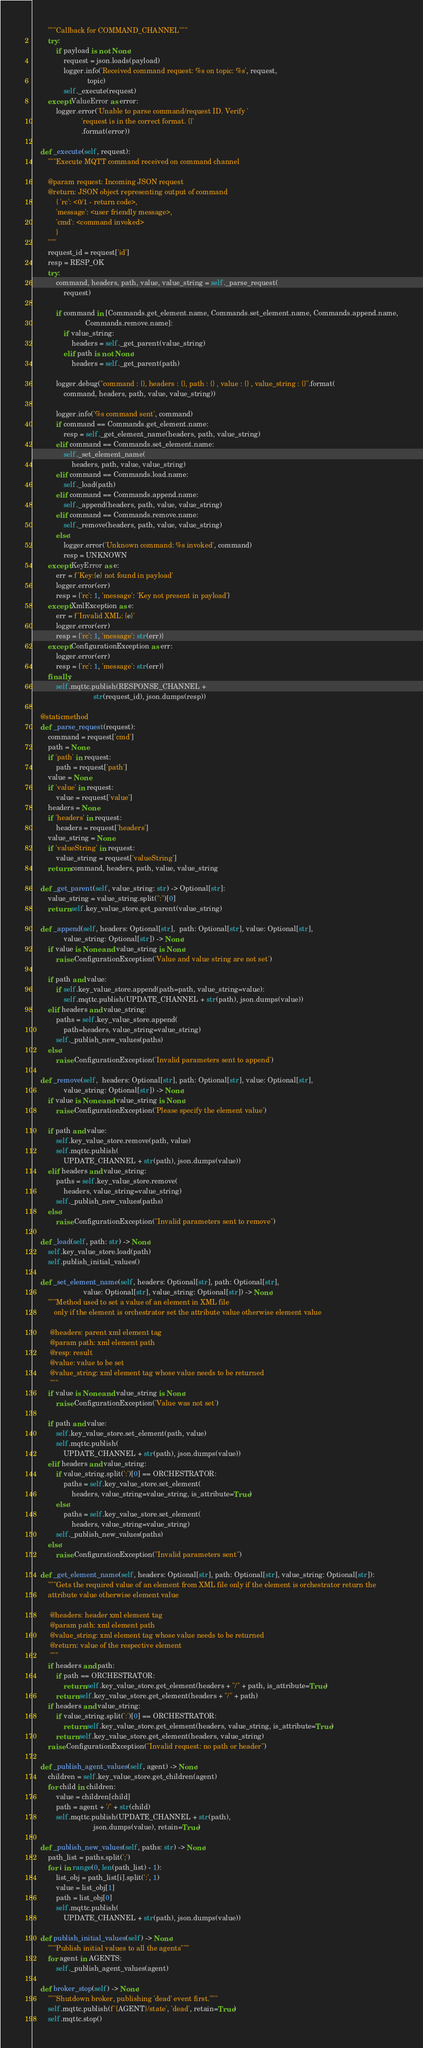Convert code to text. <code><loc_0><loc_0><loc_500><loc_500><_Python_>        """Callback for COMMAND_CHANNEL"""
        try:
            if payload is not None:
                request = json.loads(payload)
                logger.info('Received command request: %s on topic: %s', request,
                            topic)
                self._execute(request)
        except ValueError as error:
            logger.error('Unable to parse command/request ID. Verify '
                         'request is in the correct format. {}'
                         .format(error))

    def _execute(self, request):
        """Execute MQTT command received on command channel

        @param request: Incoming JSON request
        @return: JSON object representing output of command
            { 'rc': <0/1 - return code>,
            'message': <user friendly message>,
            'cmd': <command invoked>
            }
        """
        request_id = request['id']
        resp = RESP_OK
        try:
            command, headers, path, value, value_string = self._parse_request(
                request)

            if command in [Commands.get_element.name, Commands.set_element.name, Commands.append.name,
                           Commands.remove.name]:
                if value_string:
                    headers = self._get_parent(value_string)
                elif path is not None:
                    headers = self._get_parent(path)

            logger.debug("command : {}, headers : {}, path : {} , value : {} , value_string : {}".format(
                command, headers, path, value, value_string))

            logger.info('%s command sent', command)
            if command == Commands.get_element.name:
                resp = self._get_element_name(headers, path, value_string)
            elif command == Commands.set_element.name:
                self._set_element_name(
                    headers, path, value, value_string)
            elif command == Commands.load.name:
                self._load(path)
            elif command == Commands.append.name:
                self._append(headers, path, value, value_string)
            elif command == Commands.remove.name:
                self._remove(headers, path, value, value_string)
            else:
                logger.error('Unknown command: %s invoked', command)
                resp = UNKNOWN
        except KeyError as e:
            err = f'Key:{e} not found in payload'
            logger.error(err)
            resp = {'rc': 1, 'message': 'Key not present in payload'}
        except XmlException as e:
            err = f'Invalid XML: {e}'
            logger.error(err)
            resp = {'rc': 1, 'message': str(err)}
        except ConfigurationException as err:
            logger.error(err)
            resp = {'rc': 1, 'message': str(err)}
        finally:
            self.mqttc.publish(RESPONSE_CHANNEL +
                               str(request_id), json.dumps(resp))

    @staticmethod
    def _parse_request(request):
        command = request['cmd']
        path = None
        if 'path' in request:
            path = request['path']
        value = None
        if 'value' in request:
            value = request['value']
        headers = None
        if 'headers' in request:
            headers = request['headers']
        value_string = None
        if 'valueString' in request:
            value_string = request['valueString']
        return command, headers, path, value, value_string

    def _get_parent(self, value_string: str) -> Optional[str]:
        value_string = value_string.split(":")[0]
        return self.key_value_store.get_parent(value_string)

    def _append(self, headers: Optional[str],  path: Optional[str], value: Optional[str],
                value_string: Optional[str]) -> None:
        if value is None and value_string is None:
            raise ConfigurationException('Value and value string are not set')

        if path and value:
            if self.key_value_store.append(path=path, value_string=value):
                self.mqttc.publish(UPDATE_CHANNEL + str(path), json.dumps(value))
        elif headers and value_string:
            paths = self.key_value_store.append(
                path=headers, value_string=value_string)
            self._publish_new_values(paths)
        else:
            raise ConfigurationException('Invalid parameters sent to append')

    def _remove(self,  headers: Optional[str], path: Optional[str], value: Optional[str],
                value_string: Optional[str]) -> None:
        if value is None and value_string is None:
            raise ConfigurationException('Please specify the element value')

        if path and value:
            self.key_value_store.remove(path, value)
            self.mqttc.publish(
                UPDATE_CHANNEL + str(path), json.dumps(value))
        elif headers and value_string:
            paths = self.key_value_store.remove(
                headers, value_string=value_string)
            self._publish_new_values(paths)
        else:
            raise ConfigurationException("Invalid parameters sent to remove")

    def _load(self, path: str) -> None:
        self.key_value_store.load(path)
        self.publish_initial_values()

    def _set_element_name(self, headers: Optional[str], path: Optional[str],
                          value: Optional[str], value_string: Optional[str]) -> None:
        """Method used to set a value of an element in XML file
           only if the element is orchestrator set the attribute value otherwise element value

         @headers: parent xml element tag
         @param path: xml element path
         @resp: result
         @value: value to be set
         @value_string: xml element tag whose value needs to be returned
         """
        if value is None and value_string is None:
            raise ConfigurationException('Value was not set')

        if path and value:
            self.key_value_store.set_element(path, value)
            self.mqttc.publish(
                UPDATE_CHANNEL + str(path), json.dumps(value))
        elif headers and value_string:
            if value_string.split(':')[0] == ORCHESTRATOR:
                paths = self.key_value_store.set_element(
                    headers, value_string=value_string, is_attribute=True)
            else:
                paths = self.key_value_store.set_element(
                    headers, value_string=value_string)
            self._publish_new_values(paths)
        else:
            raise ConfigurationException("Invalid parameters sent")

    def _get_element_name(self, headers: Optional[str], path: Optional[str], value_string: Optional[str]):
        """Gets the required value of an element from XML file only if the element is orchestrator return the
        attribute value otherwise element value

         @headers: header xml element tag
         @param path: xml element path
         @value_string: xml element tag whose value needs to be returned
         @return: value of the respective element
         """
        if headers and path:
            if path == ORCHESTRATOR:
                return self.key_value_store.get_element(headers + "/" + path, is_attribute=True)
            return self.key_value_store.get_element(headers + "/" + path)
        if headers and value_string:
            if value_string.split(':')[0] == ORCHESTRATOR:
                return self.key_value_store.get_element(headers, value_string, is_attribute=True)
            return self.key_value_store.get_element(headers, value_string)
        raise ConfigurationException("Invalid request: no path or header")

    def _publish_agent_values(self, agent) -> None:
        children = self.key_value_store.get_children(agent)
        for child in children:
            value = children[child]
            path = agent + '/' + str(child)
            self.mqttc.publish(UPDATE_CHANNEL + str(path),
                               json.dumps(value), retain=True)

    def _publish_new_values(self, paths: str) -> None:
        path_list = paths.split(';')
        for i in range(0, len(path_list) - 1):
            list_obj = path_list[i].split(':', 1)
            value = list_obj[1]
            path = list_obj[0]
            self.mqttc.publish(
                UPDATE_CHANNEL + str(path), json.dumps(value))

    def publish_initial_values(self) -> None:
        """Publish initial values to all the agents"""
        for agent in AGENTS:
            self._publish_agent_values(agent)

    def broker_stop(self) -> None:
        """Shutdown broker, publishing 'dead' event first."""
        self.mqttc.publish(f'{AGENT}/state', 'dead', retain=True)
        self.mqttc.stop()
</code> 